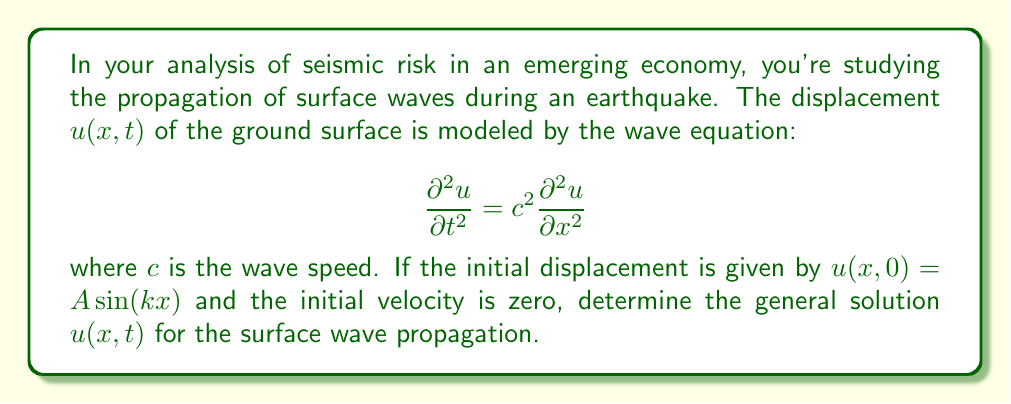Can you solve this math problem? To solve this wave equation with the given initial conditions, we follow these steps:

1) The general solution of the wave equation is of the form:
   $$u(x,t) = F(x-ct) + G(x+ct)$$
   where $F$ and $G$ are arbitrary functions.

2) Given the initial displacement $u(x,0) = A \sin(kx)$, we can write:
   $$F(x) + G(x) = A \sin(kx)$$

3) The initial velocity being zero means:
   $$\frac{\partial u}{\partial t}(x,0) = c[F'(x) - G'(x)] = 0$$
   This implies $F'(x) = G'(x)$

4) Integrating the above, we get:
   $$F(x) = G(x) + \text{constant}$$

5) From steps 2 and 4, we can deduce:
   $$F(x) = G(x) = \frac{A}{2} \sin(kx)$$

6) Substituting these into the general solution:
   $$u(x,t) = \frac{A}{2} \sin(k(x-ct)) + \frac{A}{2} \sin(k(x+ct))$$

7) Using the trigonometric identity for the sum of sines:
   $$u(x,t) = A \sin(kx) \cos(kct)$$

This is the general solution for the surface wave propagation given the initial conditions.
Answer: $u(x,t) = A \sin(kx) \cos(kct)$ 